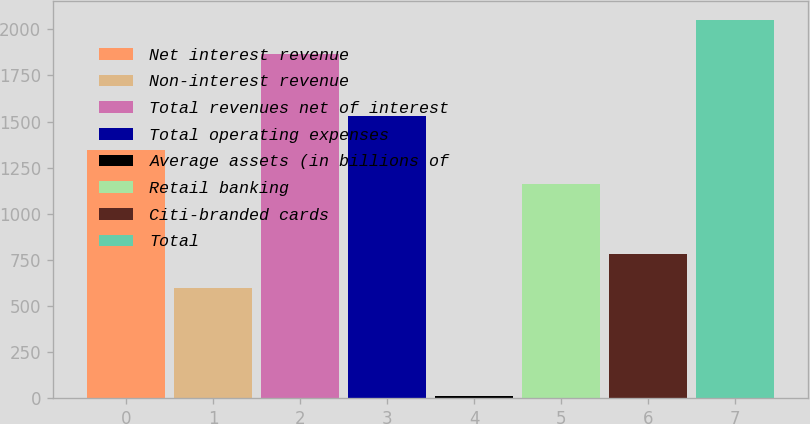Convert chart to OTSL. <chart><loc_0><loc_0><loc_500><loc_500><bar_chart><fcel>Net interest revenue<fcel>Non-interest revenue<fcel>Total revenues net of interest<fcel>Total operating expenses<fcel>Average assets (in billions of<fcel>Retail banking<fcel>Citi-branded cards<fcel>Total<nl><fcel>1345.2<fcel>596<fcel>1865<fcel>1530.4<fcel>13<fcel>1160<fcel>781.2<fcel>2050.2<nl></chart> 